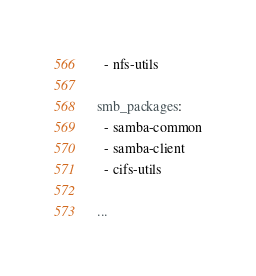<code> <loc_0><loc_0><loc_500><loc_500><_YAML_>  - nfs-utils

smb_packages:
  - samba-common
  - samba-client
  - cifs-utils

...
</code> 